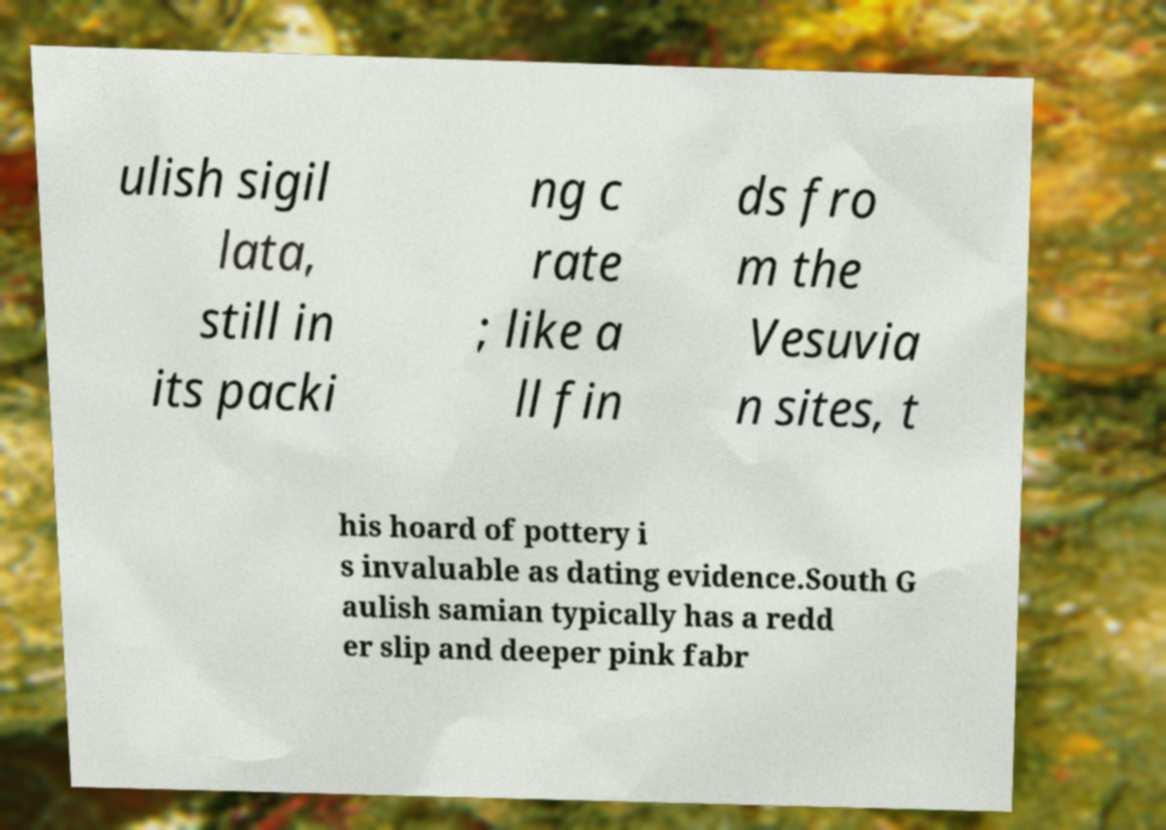What messages or text are displayed in this image? I need them in a readable, typed format. ulish sigil lata, still in its packi ng c rate ; like a ll fin ds fro m the Vesuvia n sites, t his hoard of pottery i s invaluable as dating evidence.South G aulish samian typically has a redd er slip and deeper pink fabr 